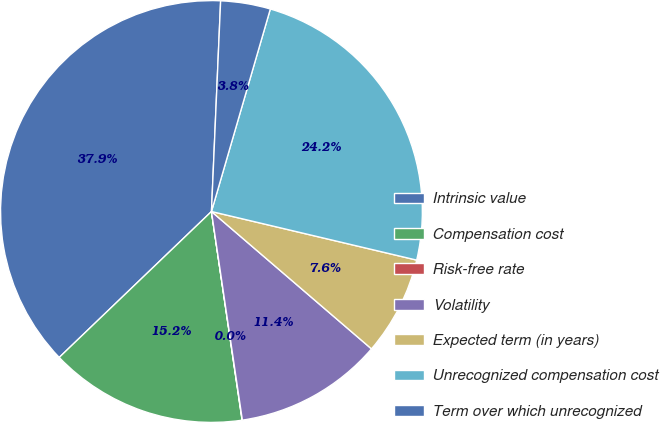<chart> <loc_0><loc_0><loc_500><loc_500><pie_chart><fcel>Intrinsic value<fcel>Compensation cost<fcel>Risk-free rate<fcel>Volatility<fcel>Expected term (in years)<fcel>Unrecognized compensation cost<fcel>Term over which unrecognized<nl><fcel>37.86%<fcel>15.16%<fcel>0.02%<fcel>11.37%<fcel>7.59%<fcel>24.2%<fcel>3.81%<nl></chart> 